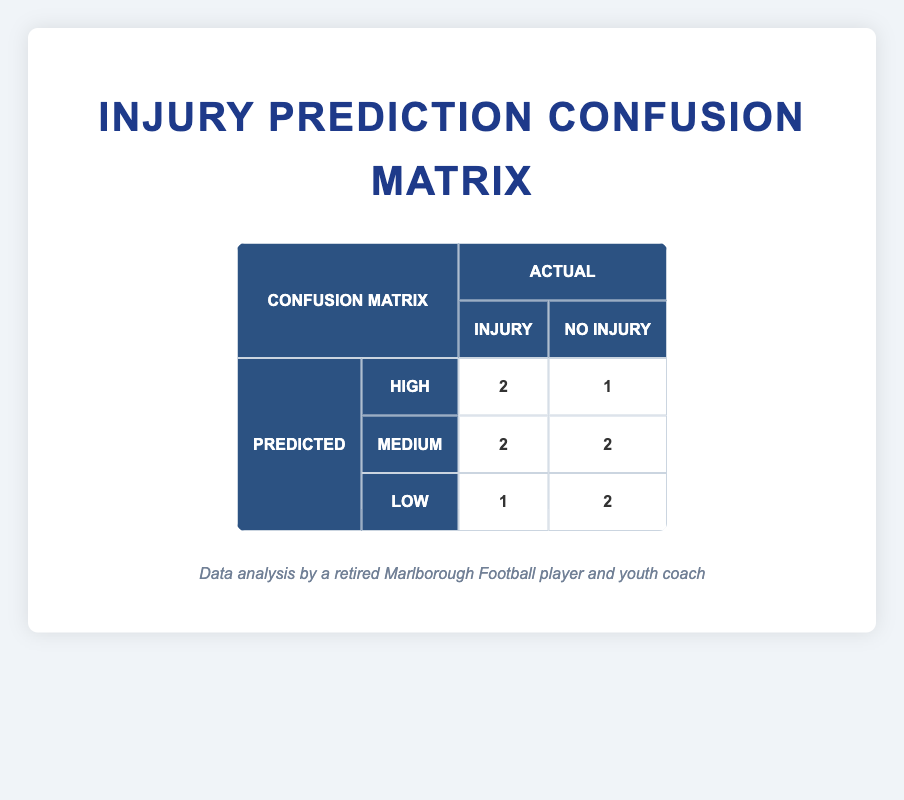What is the total number of true positives in the confusion matrix? The true positives are indicated in the matrix. For the 'High' predicted category, there are 2 true positives, while for the 'Medium' and 'Low' predicted categories, there are 0 true positives. So, the total number of true positives is 2.
Answer: 2 How many athletes were predicted to have a 'Low' injury risk that actually did not have an injury? Referring to the 'Low' row in the matrix, there are 2 true negatives (athletes who were predicted 'Low' and actually had no injury). Thus, the answer is 2.
Answer: 2 Is it true that more athletes were predicted to have a 'High' injury risk than a 'Medium' injury risk? In the confusion matrix, 3 athletes were predicted to have 'High' injury risk (2 true positives and 1 false positive), whereas 4 athletes were predicted to have 'Medium' injury risk (2 false negatives and 2 true negatives). Therefore, it is false that more athletes were predicted to be 'High' compared to 'Medium'.
Answer: No What is the total number of athletes who had an actual injury prediction of 'Yes'? To find the total, we need to look at the true positives and false negatives for all categories. There are 2 true positives for 'High', 2 false negatives for 'Medium', and 1 false negative for 'Low'. So, the total is 2 + 2 + 1 = 5.
Answer: 5 How many athletes were correctly predicted to be injured? To find this, we look at the true positives in the matrix. Under the 'High' predicted category, there are 2 true positives. In the 'Medium' predicted category, there are 0 true positives, and under 'Low', there are also 0 true positives. Therefore, the total is 2.
Answer: 2 What proportion of the 'Medium' predictions were incorrect? For the 'Medium' category, there were 2 false negatives and 2 true negatives, making a total of 4 predictions. The incorrect predictions (false negatives) were 2 out of 4. Therefore, the proportion is 2/4 or 0.5.
Answer: 0.5 How many athletes in total did not sustain an injury? The athletes who did not have an injury are counted as true negatives and false positives. In total, we have 2 true negatives (for 'Medium') and 2 true negatives (for 'Low'), and 1 false positive (for 'High'). This means 2 + 2 + 1 = 5 athletes did not sustain an injury.
Answer: 5 How many injuries were predicted in total? To find the total predictions of injuries, we can sum the true positives and false positives from the 'High' and 'Medium' predictions. For 'High', there were 2 true positives and 1 false positive, and for 'Medium', there were 0 true positives and 2 false negatives. The total predicted injuries are 2 + 1 + 0 = 3. So, the correct answer is 3.
Answer: 3 